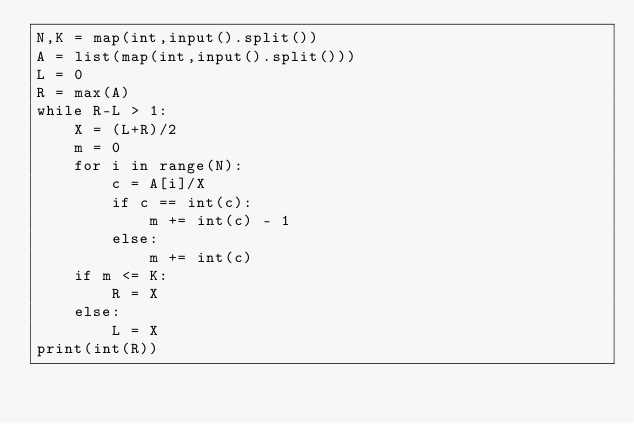Convert code to text. <code><loc_0><loc_0><loc_500><loc_500><_Python_>N,K = map(int,input().split())
A = list(map(int,input().split()))
L = 0
R = max(A)
while R-L > 1:
    X = (L+R)/2
    m = 0
    for i in range(N):
        c = A[i]/X
        if c == int(c):
            m += int(c) - 1
        else:
            m += int(c)
    if m <= K:
        R = X
    else:
        L = X
print(int(R))
</code> 